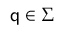Convert formula to latex. <formula><loc_0><loc_0><loc_500><loc_500>q \in \Sigma</formula> 